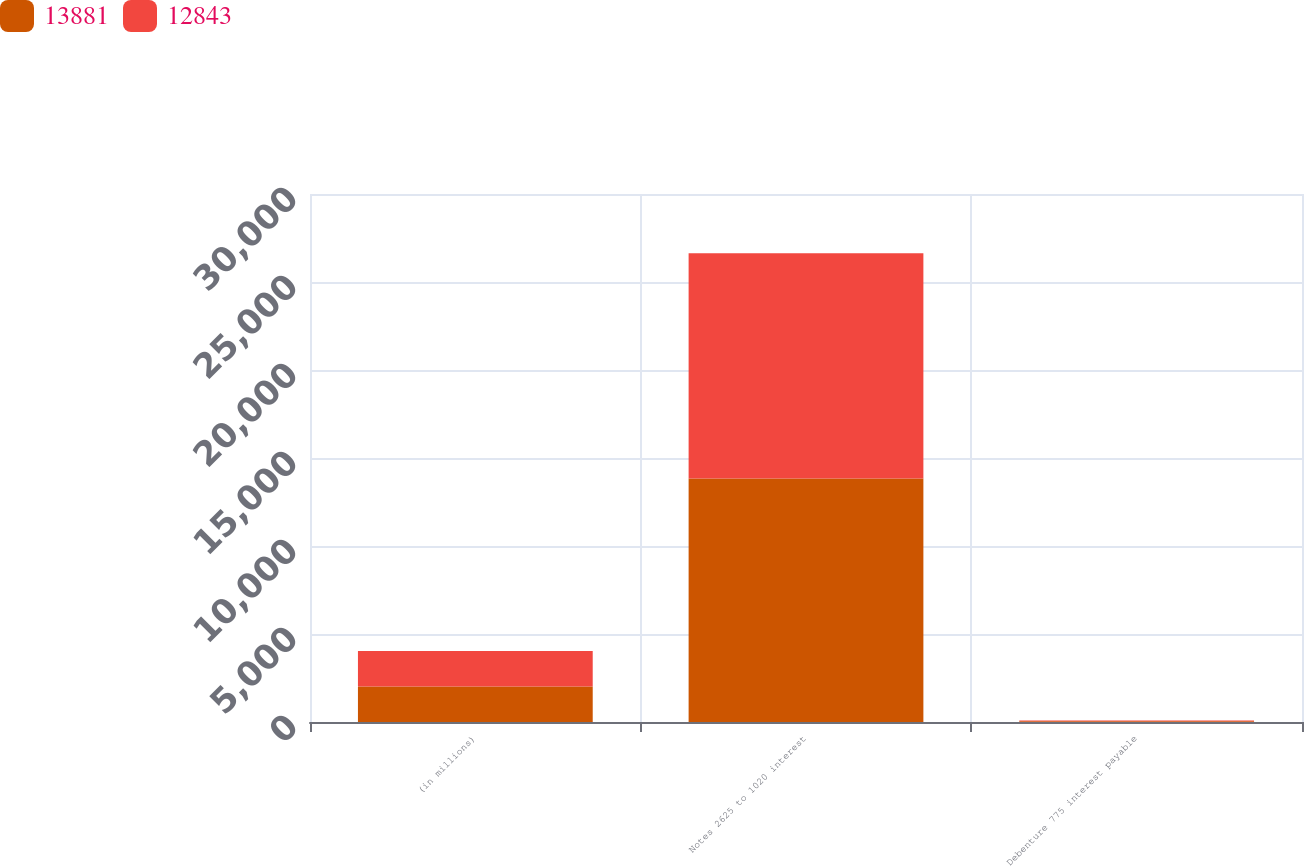<chart> <loc_0><loc_0><loc_500><loc_500><stacked_bar_chart><ecel><fcel>(in millions)<fcel>Notes 2625 to 1020 interest<fcel>Debenture 775 interest payable<nl><fcel>13881<fcel>2016<fcel>13839<fcel>42<nl><fcel>12843<fcel>2015<fcel>12789<fcel>42<nl></chart> 